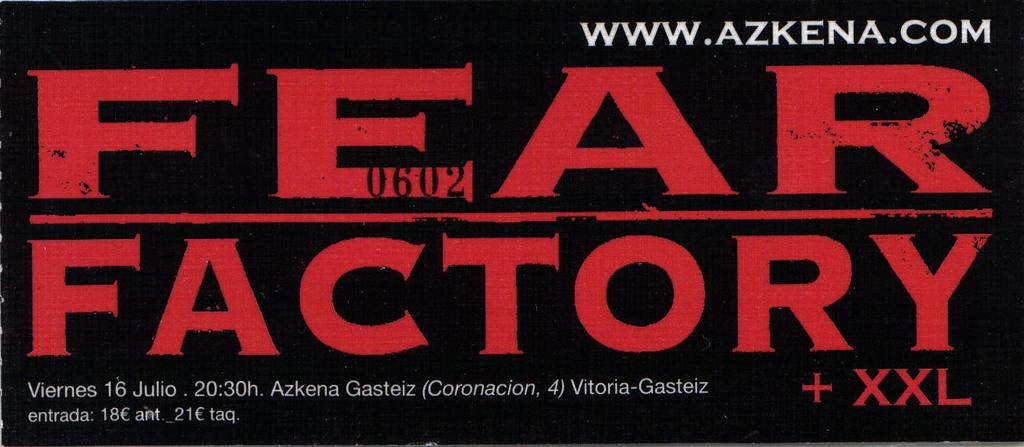Provide a one-sentence caption for the provided image. A image of a poster for Fear Factory + XXL with the website www.azkena.com on it is shown. 